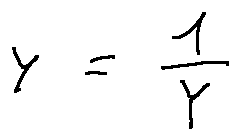Convert formula to latex. <formula><loc_0><loc_0><loc_500><loc_500>y = \frac { 1 } { Y }</formula> 